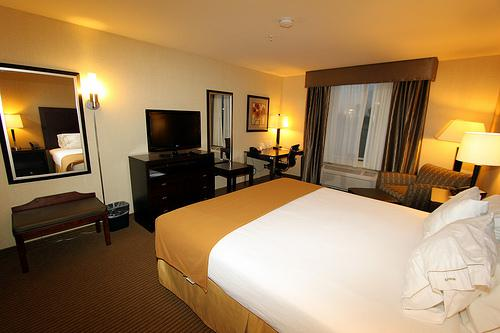Question: where is this room?
Choices:
A. In a court house.
B. In a home.
C. In a mall.
D. In a hotel.
Answer with the letter. Answer: D Question: who stays in this room?
Choices:
A. Relatives.
B. Children.
C. Guests.
D. Parents.
Answer with the letter. Answer: C Question: what is above the bench?
Choices:
A. Street sign.
B. A ceiling.
C. The sky.
D. Mirror.
Answer with the letter. Answer: D Question: why are the lights on?
Choices:
A. To give light to flowers.
B. To make someone think one is at home.
C. To waste electricity.
D. So people can see.
Answer with the letter. Answer: D Question: when is it?
Choices:
A. Day time.
B. Night time.
C. Noon.
D. Dawn.
Answer with the letter. Answer: B 